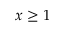<formula> <loc_0><loc_0><loc_500><loc_500>x \geq 1</formula> 